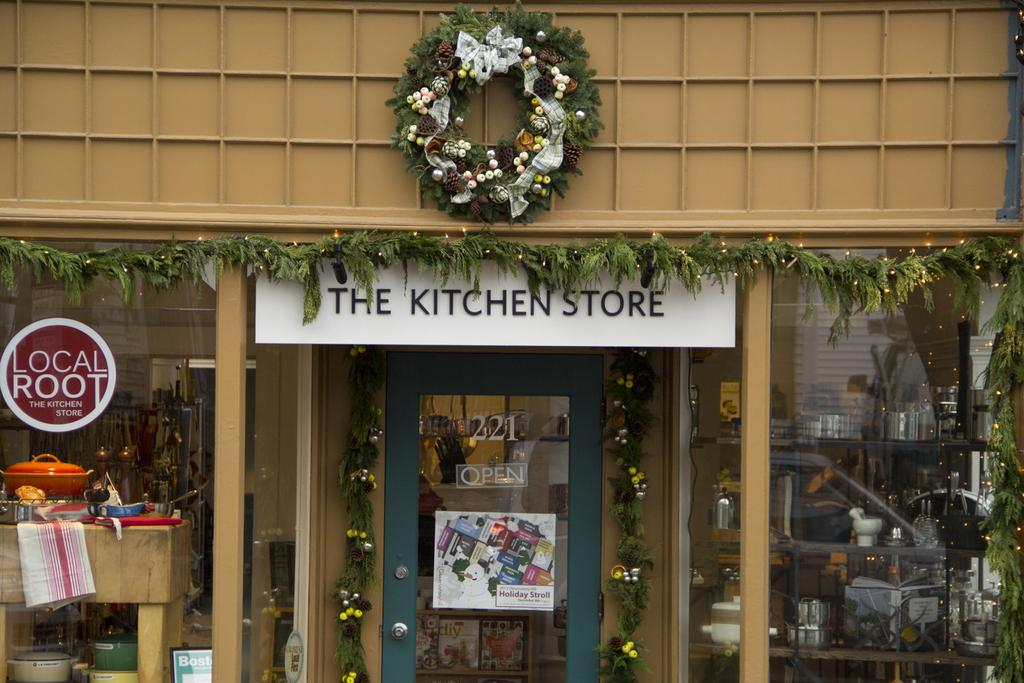<image>
Create a compact narrative representing the image presented. The Kitchen Store displaying various kitchen gadgets and pots for window shopping. 